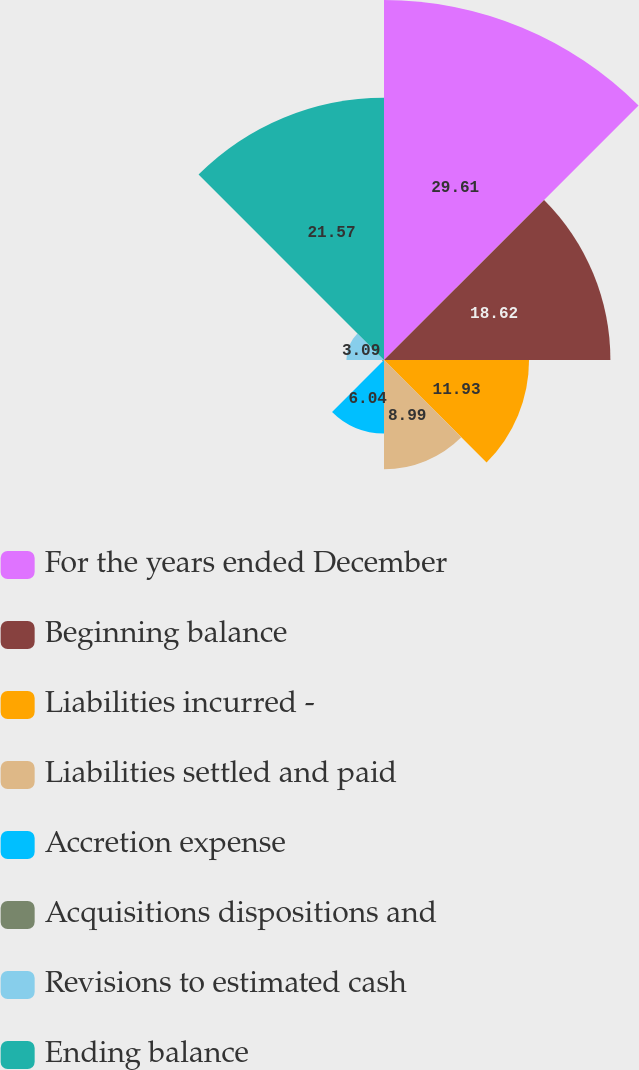<chart> <loc_0><loc_0><loc_500><loc_500><pie_chart><fcel>For the years ended December<fcel>Beginning balance<fcel>Liabilities incurred -<fcel>Liabilities settled and paid<fcel>Accretion expense<fcel>Acquisitions dispositions and<fcel>Revisions to estimated cash<fcel>Ending balance<nl><fcel>29.61%<fcel>18.62%<fcel>11.93%<fcel>8.99%<fcel>6.04%<fcel>0.15%<fcel>3.09%<fcel>21.57%<nl></chart> 